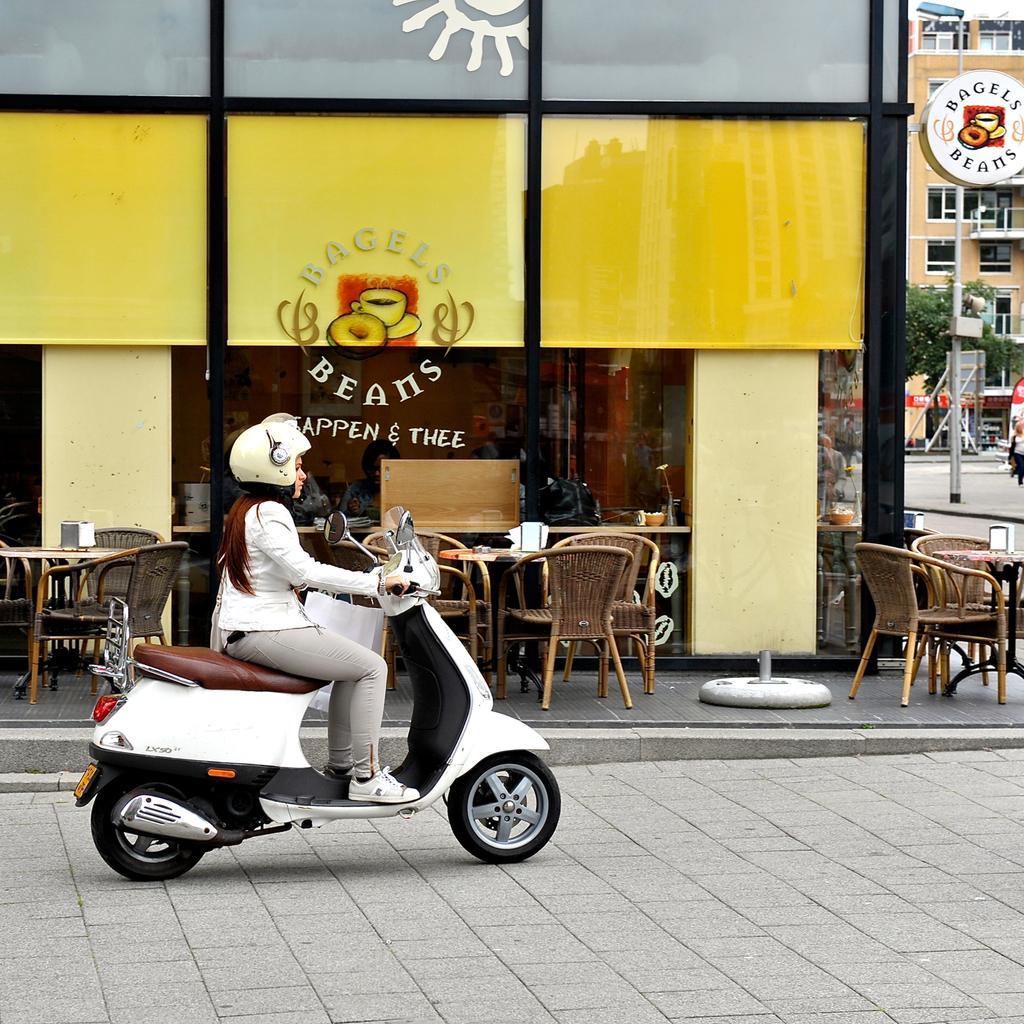Could you give a brief overview of what you see in this image? In this picture we can see a woman riding a two wheeler. She is wearing a white helmet. In the backdrop we can find a restaurant with some tables and chairs, and in the right there is a road. 